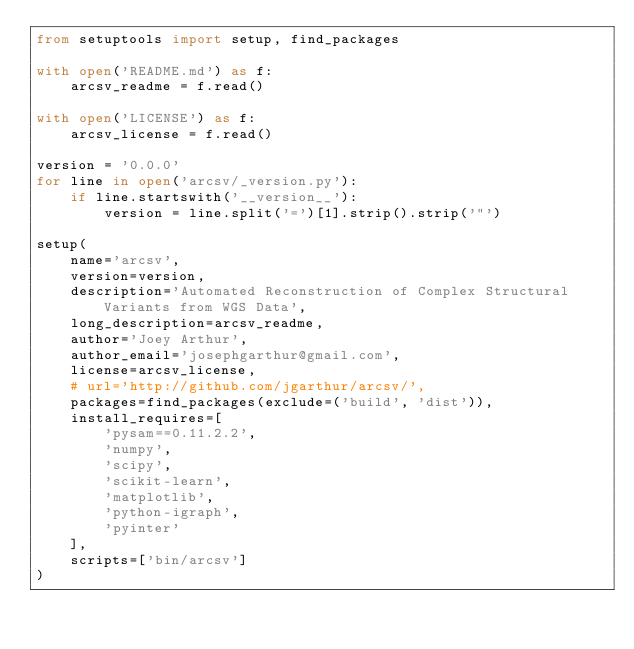Convert code to text. <code><loc_0><loc_0><loc_500><loc_500><_Python_>from setuptools import setup, find_packages

with open('README.md') as f:
    arcsv_readme = f.read()

with open('LICENSE') as f:
    arcsv_license = f.read()

version = '0.0.0'
for line in open('arcsv/_version.py'):
    if line.startswith('__version__'):
        version = line.split('=')[1].strip().strip('"')

setup(
    name='arcsv',
    version=version,
    description='Automated Reconstruction of Complex Structural Variants from WGS Data',
    long_description=arcsv_readme,
    author='Joey Arthur',
    author_email='josephgarthur@gmail.com',
    license=arcsv_license,
    # url='http://github.com/jgarthur/arcsv/',
    packages=find_packages(exclude=('build', 'dist')),
    install_requires=[
        'pysam==0.11.2.2',
        'numpy',
        'scipy',
        'scikit-learn',
        'matplotlib',
        'python-igraph',
        'pyinter'
    ],
    scripts=['bin/arcsv']
)
</code> 